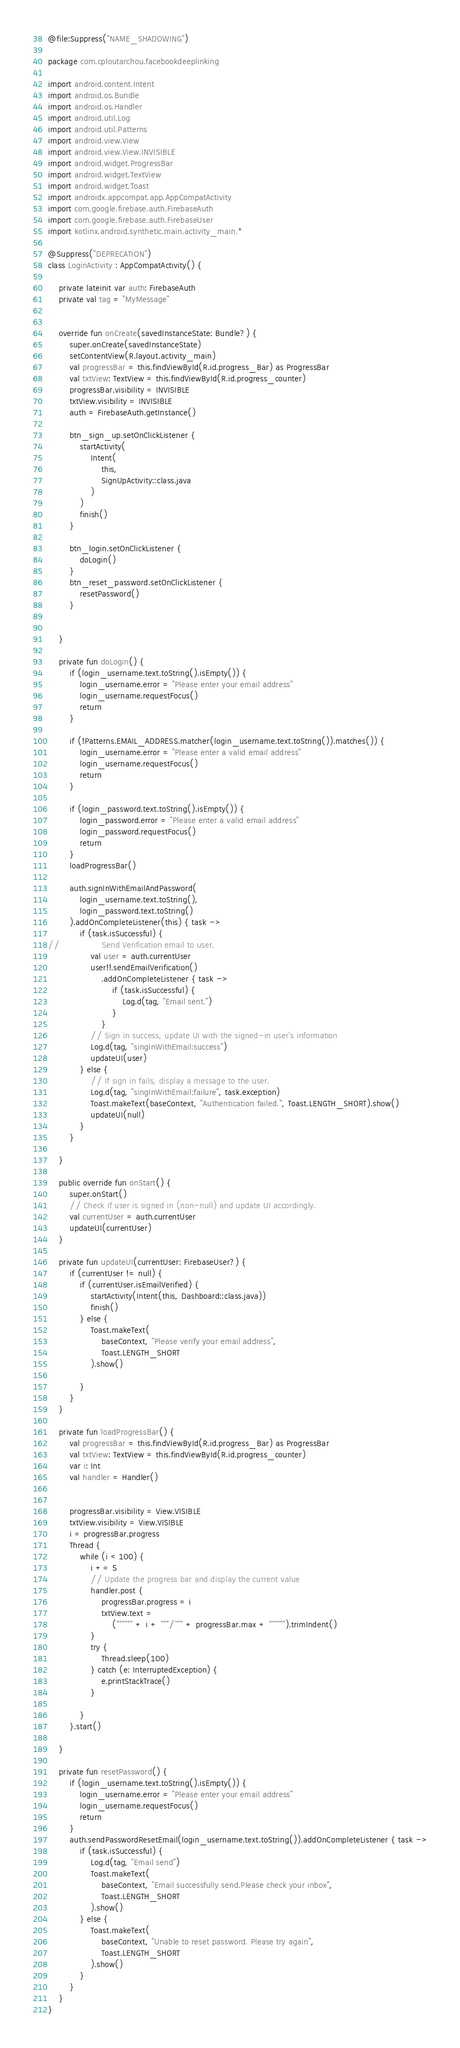Convert code to text. <code><loc_0><loc_0><loc_500><loc_500><_Kotlin_>@file:Suppress("NAME_SHADOWING")

package com.cploutarchou.facebookdeeplinking

import android.content.Intent
import android.os.Bundle
import android.os.Handler
import android.util.Log
import android.util.Patterns
import android.view.View
import android.view.View.INVISIBLE
import android.widget.ProgressBar
import android.widget.TextView
import android.widget.Toast
import androidx.appcompat.app.AppCompatActivity
import com.google.firebase.auth.FirebaseAuth
import com.google.firebase.auth.FirebaseUser
import kotlinx.android.synthetic.main.activity_main.*

@Suppress("DEPRECATION")
class LoginActivity : AppCompatActivity() {

    private lateinit var auth: FirebaseAuth
    private val tag = "MyMessage"


    override fun onCreate(savedInstanceState: Bundle?) {
        super.onCreate(savedInstanceState)
        setContentView(R.layout.activity_main)
        val progressBar = this.findViewById(R.id.progress_Bar) as ProgressBar
        val txtView: TextView = this.findViewById(R.id.progress_counter)
        progressBar.visibility = INVISIBLE
        txtView.visibility = INVISIBLE
        auth = FirebaseAuth.getInstance()

        btn_sign_up.setOnClickListener {
            startActivity(
                Intent(
                    this,
                    SignUpActivity::class.java
                )
            )
            finish()
        }

        btn_login.setOnClickListener {
            doLogin()
        }
        btn_reset_password.setOnClickListener {
            resetPassword()
        }


    }

    private fun doLogin() {
        if (login_username.text.toString().isEmpty()) {
            login_username.error = "Please enter your email address"
            login_username.requestFocus()
            return
        }

        if (!Patterns.EMAIL_ADDRESS.matcher(login_username.text.toString()).matches()) {
            login_username.error = "Please enter a valid email address"
            login_username.requestFocus()
            return
        }

        if (login_password.text.toString().isEmpty()) {
            login_password.error = "Please enter a valid email address"
            login_password.requestFocus()
            return
        }
        loadProgressBar()

        auth.signInWithEmailAndPassword(
            login_username.text.toString(),
            login_password.text.toString()
        ).addOnCompleteListener(this) { task ->
            if (task.isSuccessful) {
//                Send Verification email to user.
                val user = auth.currentUser
                user!!.sendEmailVerification()
                    .addOnCompleteListener { task ->
                        if (task.isSuccessful) {
                            Log.d(tag, "Email sent.")
                        }
                    }
                // Sign in success, update UI with the signed-in user's information
                Log.d(tag, "singInWithEmail:success")
                updateUI(user)
            } else {
                // If sign in fails, display a message to the user.
                Log.d(tag, "singInWithEmail:failure", task.exception)
                Toast.makeText(baseContext, "Authentication failed.", Toast.LENGTH_SHORT).show()
                updateUI(null)
            }
        }

    }

    public override fun onStart() {
        super.onStart()
        // Check if user is signed in (non-null) and update UI accordingly.
        val currentUser = auth.currentUser
        updateUI(currentUser)
    }

    private fun updateUI(currentUser: FirebaseUser?) {
        if (currentUser != null) {
            if (currentUser.isEmailVerified) {
                startActivity(Intent(this, Dashboard::class.java))
                finish()
            } else {
                Toast.makeText(
                    baseContext, "Please verify your email address",
                    Toast.LENGTH_SHORT
                ).show()

            }
        }
    }

    private fun loadProgressBar() {
        val progressBar = this.findViewById(R.id.progress_Bar) as ProgressBar
        val txtView: TextView = this.findViewById(R.id.progress_counter)
        var i: Int
        val handler = Handler()


        progressBar.visibility = View.VISIBLE
        txtView.visibility = View.VISIBLE
        i = progressBar.progress
        Thread {
            while (i < 100) {
                i += 5
                // Update the progress bar and display the current value
                handler.post {
                    progressBar.progress = i
                    txtView.text =
                        ("""""" + i + """/""" + progressBar.max + """""").trimIndent()
                }
                try {
                    Thread.sleep(100)
                } catch (e: InterruptedException) {
                    e.printStackTrace()
                }

            }
        }.start()

    }

    private fun resetPassword() {
        if (login_username.text.toString().isEmpty()) {
            login_username.error = "Please enter your email address"
            login_username.requestFocus()
            return
        }
        auth.sendPasswordResetEmail(login_username.text.toString()).addOnCompleteListener { task ->
            if (task.isSuccessful) {
                Log.d(tag, "Email send")
                Toast.makeText(
                    baseContext, "Email successfully send.Please check your inbox",
                    Toast.LENGTH_SHORT
                ).show()
            } else {
                Toast.makeText(
                    baseContext, "Unable to reset password. Please try again",
                    Toast.LENGTH_SHORT
                ).show()
            }
        }
    }
}





</code> 